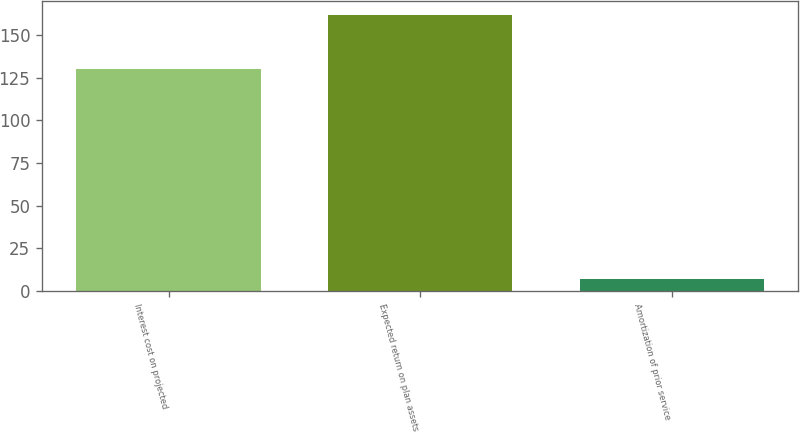Convert chart. <chart><loc_0><loc_0><loc_500><loc_500><bar_chart><fcel>Interest cost on projected<fcel>Expected return on plan assets<fcel>Amortization of prior service<nl><fcel>130<fcel>162<fcel>7<nl></chart> 